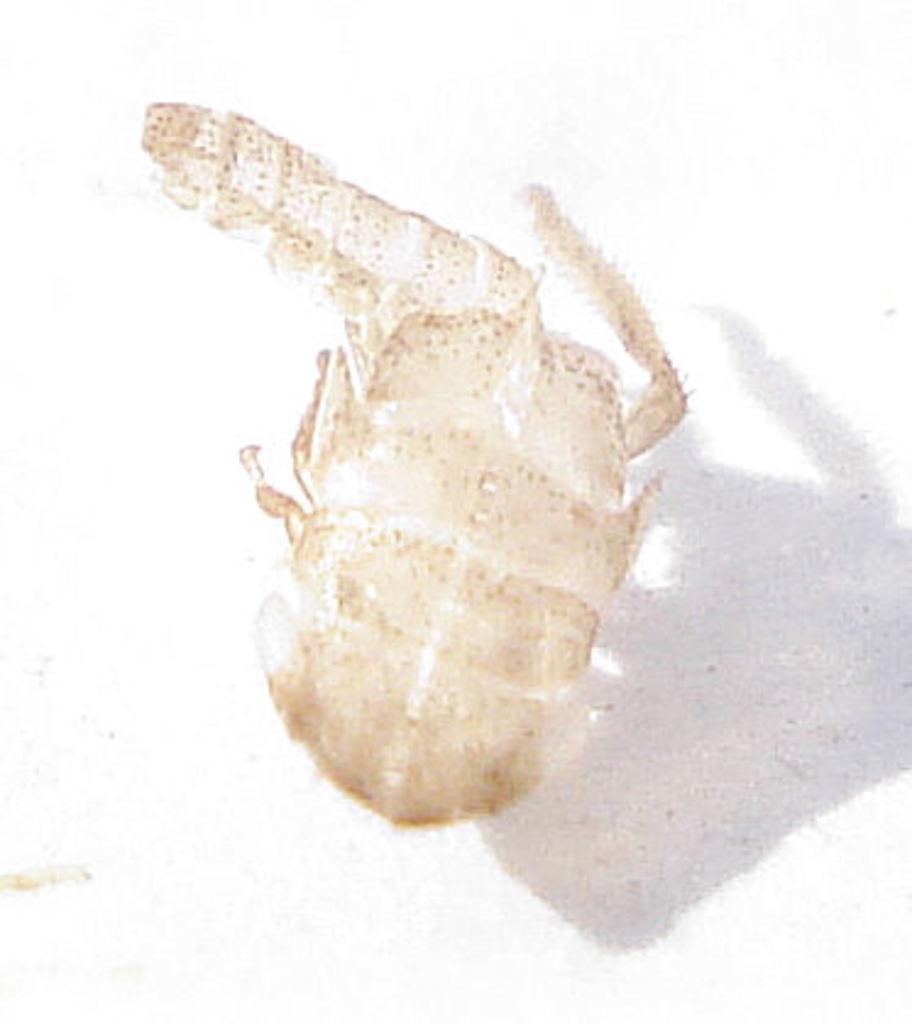Please provide a concise description of this image. As we can see in the image there is an insect. 